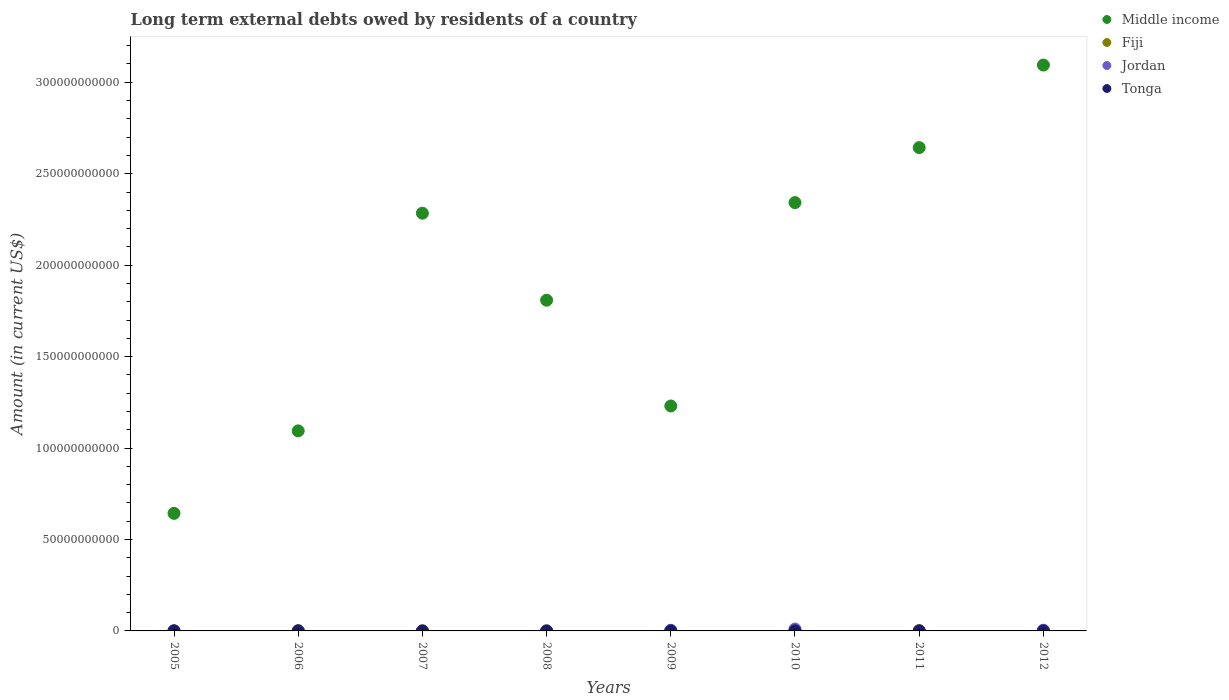Is the number of dotlines equal to the number of legend labels?
Provide a short and direct response. No. What is the amount of long-term external debts owed by residents in Middle income in 2006?
Provide a short and direct response. 1.09e+11. Across all years, what is the maximum amount of long-term external debts owed by residents in Middle income?
Make the answer very short. 3.09e+11. Across all years, what is the minimum amount of long-term external debts owed by residents in Middle income?
Your answer should be very brief. 6.43e+1. What is the total amount of long-term external debts owed by residents in Middle income in the graph?
Give a very brief answer. 1.51e+12. What is the difference between the amount of long-term external debts owed by residents in Tonga in 2008 and that in 2009?
Offer a terse response. -1.02e+07. What is the difference between the amount of long-term external debts owed by residents in Jordan in 2011 and the amount of long-term external debts owed by residents in Tonga in 2010?
Ensure brevity in your answer.  -3.82e+07. What is the average amount of long-term external debts owed by residents in Fiji per year?
Offer a terse response. 5.20e+07. In the year 2006, what is the difference between the amount of long-term external debts owed by residents in Fiji and amount of long-term external debts owed by residents in Middle income?
Keep it short and to the point. -1.09e+11. What is the ratio of the amount of long-term external debts owed by residents in Tonga in 2005 to that in 2008?
Give a very brief answer. 0.18. What is the difference between the highest and the second highest amount of long-term external debts owed by residents in Tonga?
Your answer should be very brief. 4.60e+06. What is the difference between the highest and the lowest amount of long-term external debts owed by residents in Jordan?
Provide a short and direct response. 1.02e+09. In how many years, is the amount of long-term external debts owed by residents in Middle income greater than the average amount of long-term external debts owed by residents in Middle income taken over all years?
Keep it short and to the point. 4. Is the sum of the amount of long-term external debts owed by residents in Tonga in 2005 and 2012 greater than the maximum amount of long-term external debts owed by residents in Fiji across all years?
Ensure brevity in your answer.  No. Is it the case that in every year, the sum of the amount of long-term external debts owed by residents in Tonga and amount of long-term external debts owed by residents in Jordan  is greater than the amount of long-term external debts owed by residents in Fiji?
Offer a very short reply. No. Is the amount of long-term external debts owed by residents in Jordan strictly greater than the amount of long-term external debts owed by residents in Middle income over the years?
Provide a short and direct response. No. Is the amount of long-term external debts owed by residents in Fiji strictly less than the amount of long-term external debts owed by residents in Middle income over the years?
Make the answer very short. Yes. Are the values on the major ticks of Y-axis written in scientific E-notation?
Your answer should be compact. No. Does the graph contain any zero values?
Ensure brevity in your answer.  Yes. What is the title of the graph?
Your response must be concise. Long term external debts owed by residents of a country. Does "Bhutan" appear as one of the legend labels in the graph?
Give a very brief answer. No. What is the label or title of the X-axis?
Your answer should be compact. Years. What is the label or title of the Y-axis?
Give a very brief answer. Amount (in current US$). What is the Amount (in current US$) of Middle income in 2005?
Offer a terse response. 6.43e+1. What is the Amount (in current US$) of Fiji in 2005?
Make the answer very short. 5.53e+06. What is the Amount (in current US$) in Jordan in 2005?
Your answer should be very brief. 6.78e+07. What is the Amount (in current US$) of Tonga in 2005?
Offer a very short reply. 8.68e+05. What is the Amount (in current US$) of Middle income in 2006?
Provide a succinct answer. 1.09e+11. What is the Amount (in current US$) in Fiji in 2006?
Keep it short and to the point. 1.55e+08. What is the Amount (in current US$) of Middle income in 2007?
Your answer should be compact. 2.28e+11. What is the Amount (in current US$) in Fiji in 2007?
Offer a terse response. 2.23e+06. What is the Amount (in current US$) in Jordan in 2007?
Provide a short and direct response. 0. What is the Amount (in current US$) of Tonga in 2007?
Keep it short and to the point. 8.95e+05. What is the Amount (in current US$) of Middle income in 2008?
Offer a very short reply. 1.81e+11. What is the Amount (in current US$) in Fiji in 2008?
Offer a terse response. 5.63e+06. What is the Amount (in current US$) in Tonga in 2008?
Your response must be concise. 4.80e+06. What is the Amount (in current US$) of Middle income in 2009?
Your response must be concise. 1.23e+11. What is the Amount (in current US$) in Fiji in 2009?
Your answer should be very brief. 4.86e+06. What is the Amount (in current US$) in Jordan in 2009?
Make the answer very short. 3.62e+08. What is the Amount (in current US$) in Tonga in 2009?
Offer a very short reply. 1.49e+07. What is the Amount (in current US$) in Middle income in 2010?
Provide a short and direct response. 2.34e+11. What is the Amount (in current US$) in Fiji in 2010?
Your answer should be very brief. 2.35e+07. What is the Amount (in current US$) in Jordan in 2010?
Your answer should be very brief. 1.02e+09. What is the Amount (in current US$) of Tonga in 2010?
Provide a succinct answer. 3.82e+07. What is the Amount (in current US$) in Middle income in 2011?
Provide a succinct answer. 2.64e+11. What is the Amount (in current US$) of Fiji in 2011?
Provide a short and direct response. 1.52e+08. What is the Amount (in current US$) in Tonga in 2011?
Offer a very short reply. 3.36e+07. What is the Amount (in current US$) of Middle income in 2012?
Make the answer very short. 3.09e+11. What is the Amount (in current US$) in Fiji in 2012?
Offer a very short reply. 6.71e+07. What is the Amount (in current US$) of Jordan in 2012?
Give a very brief answer. 3.95e+08. What is the Amount (in current US$) in Tonga in 2012?
Provide a short and direct response. 6.46e+06. Across all years, what is the maximum Amount (in current US$) of Middle income?
Offer a terse response. 3.09e+11. Across all years, what is the maximum Amount (in current US$) of Fiji?
Keep it short and to the point. 1.55e+08. Across all years, what is the maximum Amount (in current US$) of Jordan?
Offer a terse response. 1.02e+09. Across all years, what is the maximum Amount (in current US$) in Tonga?
Provide a succinct answer. 3.82e+07. Across all years, what is the minimum Amount (in current US$) in Middle income?
Provide a succinct answer. 6.43e+1. Across all years, what is the minimum Amount (in current US$) of Fiji?
Your answer should be very brief. 2.23e+06. Across all years, what is the minimum Amount (in current US$) of Jordan?
Provide a succinct answer. 0. Across all years, what is the minimum Amount (in current US$) in Tonga?
Give a very brief answer. 0. What is the total Amount (in current US$) of Middle income in the graph?
Offer a very short reply. 1.51e+12. What is the total Amount (in current US$) of Fiji in the graph?
Your response must be concise. 4.16e+08. What is the total Amount (in current US$) in Jordan in the graph?
Ensure brevity in your answer.  1.85e+09. What is the total Amount (in current US$) in Tonga in the graph?
Offer a terse response. 9.99e+07. What is the difference between the Amount (in current US$) of Middle income in 2005 and that in 2006?
Your answer should be compact. -4.51e+1. What is the difference between the Amount (in current US$) in Fiji in 2005 and that in 2006?
Ensure brevity in your answer.  -1.50e+08. What is the difference between the Amount (in current US$) of Middle income in 2005 and that in 2007?
Your response must be concise. -1.64e+11. What is the difference between the Amount (in current US$) in Fiji in 2005 and that in 2007?
Offer a terse response. 3.30e+06. What is the difference between the Amount (in current US$) of Tonga in 2005 and that in 2007?
Make the answer very short. -2.70e+04. What is the difference between the Amount (in current US$) in Middle income in 2005 and that in 2008?
Ensure brevity in your answer.  -1.17e+11. What is the difference between the Amount (in current US$) in Fiji in 2005 and that in 2008?
Your answer should be compact. -1.01e+05. What is the difference between the Amount (in current US$) of Tonga in 2005 and that in 2008?
Your answer should be very brief. -3.93e+06. What is the difference between the Amount (in current US$) of Middle income in 2005 and that in 2009?
Ensure brevity in your answer.  -5.87e+1. What is the difference between the Amount (in current US$) of Fiji in 2005 and that in 2009?
Ensure brevity in your answer.  6.65e+05. What is the difference between the Amount (in current US$) of Jordan in 2005 and that in 2009?
Offer a very short reply. -2.94e+08. What is the difference between the Amount (in current US$) of Tonga in 2005 and that in 2009?
Give a very brief answer. -1.41e+07. What is the difference between the Amount (in current US$) of Middle income in 2005 and that in 2010?
Ensure brevity in your answer.  -1.70e+11. What is the difference between the Amount (in current US$) of Fiji in 2005 and that in 2010?
Keep it short and to the point. -1.79e+07. What is the difference between the Amount (in current US$) of Jordan in 2005 and that in 2010?
Make the answer very short. -9.57e+08. What is the difference between the Amount (in current US$) in Tonga in 2005 and that in 2010?
Keep it short and to the point. -3.74e+07. What is the difference between the Amount (in current US$) in Middle income in 2005 and that in 2011?
Your answer should be very brief. -2.00e+11. What is the difference between the Amount (in current US$) in Fiji in 2005 and that in 2011?
Provide a short and direct response. -1.46e+08. What is the difference between the Amount (in current US$) in Tonga in 2005 and that in 2011?
Give a very brief answer. -3.28e+07. What is the difference between the Amount (in current US$) of Middle income in 2005 and that in 2012?
Your response must be concise. -2.45e+11. What is the difference between the Amount (in current US$) of Fiji in 2005 and that in 2012?
Your answer should be compact. -6.16e+07. What is the difference between the Amount (in current US$) of Jordan in 2005 and that in 2012?
Provide a succinct answer. -3.27e+08. What is the difference between the Amount (in current US$) in Tonga in 2005 and that in 2012?
Provide a succinct answer. -5.59e+06. What is the difference between the Amount (in current US$) in Middle income in 2006 and that in 2007?
Offer a terse response. -1.19e+11. What is the difference between the Amount (in current US$) of Fiji in 2006 and that in 2007?
Provide a short and direct response. 1.53e+08. What is the difference between the Amount (in current US$) of Middle income in 2006 and that in 2008?
Provide a short and direct response. -7.15e+1. What is the difference between the Amount (in current US$) in Fiji in 2006 and that in 2008?
Give a very brief answer. 1.50e+08. What is the difference between the Amount (in current US$) in Middle income in 2006 and that in 2009?
Your answer should be compact. -1.36e+1. What is the difference between the Amount (in current US$) of Fiji in 2006 and that in 2009?
Make the answer very short. 1.50e+08. What is the difference between the Amount (in current US$) in Middle income in 2006 and that in 2010?
Offer a terse response. -1.25e+11. What is the difference between the Amount (in current US$) of Fiji in 2006 and that in 2010?
Give a very brief answer. 1.32e+08. What is the difference between the Amount (in current US$) in Middle income in 2006 and that in 2011?
Your response must be concise. -1.55e+11. What is the difference between the Amount (in current US$) of Fiji in 2006 and that in 2011?
Ensure brevity in your answer.  3.40e+06. What is the difference between the Amount (in current US$) in Middle income in 2006 and that in 2012?
Make the answer very short. -2.00e+11. What is the difference between the Amount (in current US$) of Fiji in 2006 and that in 2012?
Your answer should be very brief. 8.81e+07. What is the difference between the Amount (in current US$) of Middle income in 2007 and that in 2008?
Keep it short and to the point. 4.76e+1. What is the difference between the Amount (in current US$) in Fiji in 2007 and that in 2008?
Keep it short and to the point. -3.40e+06. What is the difference between the Amount (in current US$) in Tonga in 2007 and that in 2008?
Your response must be concise. -3.90e+06. What is the difference between the Amount (in current US$) in Middle income in 2007 and that in 2009?
Ensure brevity in your answer.  1.05e+11. What is the difference between the Amount (in current US$) in Fiji in 2007 and that in 2009?
Offer a very short reply. -2.64e+06. What is the difference between the Amount (in current US$) in Tonga in 2007 and that in 2009?
Offer a very short reply. -1.41e+07. What is the difference between the Amount (in current US$) in Middle income in 2007 and that in 2010?
Offer a very short reply. -5.80e+09. What is the difference between the Amount (in current US$) in Fiji in 2007 and that in 2010?
Your answer should be compact. -2.12e+07. What is the difference between the Amount (in current US$) in Tonga in 2007 and that in 2010?
Offer a very short reply. -3.74e+07. What is the difference between the Amount (in current US$) of Middle income in 2007 and that in 2011?
Give a very brief answer. -3.59e+1. What is the difference between the Amount (in current US$) of Fiji in 2007 and that in 2011?
Offer a terse response. -1.50e+08. What is the difference between the Amount (in current US$) in Tonga in 2007 and that in 2011?
Give a very brief answer. -3.28e+07. What is the difference between the Amount (in current US$) in Middle income in 2007 and that in 2012?
Provide a short and direct response. -8.10e+1. What is the difference between the Amount (in current US$) in Fiji in 2007 and that in 2012?
Offer a very short reply. -6.49e+07. What is the difference between the Amount (in current US$) of Tonga in 2007 and that in 2012?
Provide a short and direct response. -5.56e+06. What is the difference between the Amount (in current US$) of Middle income in 2008 and that in 2009?
Your answer should be compact. 5.78e+1. What is the difference between the Amount (in current US$) in Fiji in 2008 and that in 2009?
Your answer should be very brief. 7.66e+05. What is the difference between the Amount (in current US$) in Tonga in 2008 and that in 2009?
Provide a succinct answer. -1.02e+07. What is the difference between the Amount (in current US$) of Middle income in 2008 and that in 2010?
Your response must be concise. -5.34e+1. What is the difference between the Amount (in current US$) in Fiji in 2008 and that in 2010?
Provide a short and direct response. -1.78e+07. What is the difference between the Amount (in current US$) in Tonga in 2008 and that in 2010?
Your response must be concise. -3.34e+07. What is the difference between the Amount (in current US$) in Middle income in 2008 and that in 2011?
Make the answer very short. -8.34e+1. What is the difference between the Amount (in current US$) in Fiji in 2008 and that in 2011?
Provide a short and direct response. -1.46e+08. What is the difference between the Amount (in current US$) in Tonga in 2008 and that in 2011?
Offer a terse response. -2.89e+07. What is the difference between the Amount (in current US$) in Middle income in 2008 and that in 2012?
Your answer should be compact. -1.29e+11. What is the difference between the Amount (in current US$) in Fiji in 2008 and that in 2012?
Offer a very short reply. -6.15e+07. What is the difference between the Amount (in current US$) of Tonga in 2008 and that in 2012?
Make the answer very short. -1.66e+06. What is the difference between the Amount (in current US$) in Middle income in 2009 and that in 2010?
Keep it short and to the point. -1.11e+11. What is the difference between the Amount (in current US$) in Fiji in 2009 and that in 2010?
Offer a terse response. -1.86e+07. What is the difference between the Amount (in current US$) in Jordan in 2009 and that in 2010?
Offer a terse response. -6.63e+08. What is the difference between the Amount (in current US$) of Tonga in 2009 and that in 2010?
Give a very brief answer. -2.33e+07. What is the difference between the Amount (in current US$) in Middle income in 2009 and that in 2011?
Your response must be concise. -1.41e+11. What is the difference between the Amount (in current US$) of Fiji in 2009 and that in 2011?
Provide a short and direct response. -1.47e+08. What is the difference between the Amount (in current US$) of Tonga in 2009 and that in 2011?
Make the answer very short. -1.87e+07. What is the difference between the Amount (in current US$) in Middle income in 2009 and that in 2012?
Offer a very short reply. -1.86e+11. What is the difference between the Amount (in current US$) in Fiji in 2009 and that in 2012?
Make the answer very short. -6.22e+07. What is the difference between the Amount (in current US$) in Jordan in 2009 and that in 2012?
Make the answer very short. -3.30e+07. What is the difference between the Amount (in current US$) of Tonga in 2009 and that in 2012?
Offer a terse response. 8.49e+06. What is the difference between the Amount (in current US$) in Middle income in 2010 and that in 2011?
Make the answer very short. -3.01e+1. What is the difference between the Amount (in current US$) in Fiji in 2010 and that in 2011?
Give a very brief answer. -1.28e+08. What is the difference between the Amount (in current US$) of Tonga in 2010 and that in 2011?
Your response must be concise. 4.60e+06. What is the difference between the Amount (in current US$) in Middle income in 2010 and that in 2012?
Your response must be concise. -7.52e+1. What is the difference between the Amount (in current US$) of Fiji in 2010 and that in 2012?
Your answer should be compact. -4.36e+07. What is the difference between the Amount (in current US$) of Jordan in 2010 and that in 2012?
Your answer should be compact. 6.30e+08. What is the difference between the Amount (in current US$) in Tonga in 2010 and that in 2012?
Give a very brief answer. 3.18e+07. What is the difference between the Amount (in current US$) of Middle income in 2011 and that in 2012?
Offer a very short reply. -4.51e+1. What is the difference between the Amount (in current US$) in Fiji in 2011 and that in 2012?
Make the answer very short. 8.47e+07. What is the difference between the Amount (in current US$) of Tonga in 2011 and that in 2012?
Ensure brevity in your answer.  2.72e+07. What is the difference between the Amount (in current US$) in Middle income in 2005 and the Amount (in current US$) in Fiji in 2006?
Provide a short and direct response. 6.41e+1. What is the difference between the Amount (in current US$) of Middle income in 2005 and the Amount (in current US$) of Fiji in 2007?
Provide a short and direct response. 6.43e+1. What is the difference between the Amount (in current US$) in Middle income in 2005 and the Amount (in current US$) in Tonga in 2007?
Offer a very short reply. 6.43e+1. What is the difference between the Amount (in current US$) in Fiji in 2005 and the Amount (in current US$) in Tonga in 2007?
Provide a succinct answer. 4.63e+06. What is the difference between the Amount (in current US$) of Jordan in 2005 and the Amount (in current US$) of Tonga in 2007?
Your answer should be compact. 6.69e+07. What is the difference between the Amount (in current US$) of Middle income in 2005 and the Amount (in current US$) of Fiji in 2008?
Your answer should be compact. 6.43e+1. What is the difference between the Amount (in current US$) in Middle income in 2005 and the Amount (in current US$) in Tonga in 2008?
Your response must be concise. 6.43e+1. What is the difference between the Amount (in current US$) in Fiji in 2005 and the Amount (in current US$) in Tonga in 2008?
Offer a very short reply. 7.30e+05. What is the difference between the Amount (in current US$) of Jordan in 2005 and the Amount (in current US$) of Tonga in 2008?
Provide a short and direct response. 6.30e+07. What is the difference between the Amount (in current US$) in Middle income in 2005 and the Amount (in current US$) in Fiji in 2009?
Provide a succinct answer. 6.43e+1. What is the difference between the Amount (in current US$) of Middle income in 2005 and the Amount (in current US$) of Jordan in 2009?
Your response must be concise. 6.39e+1. What is the difference between the Amount (in current US$) in Middle income in 2005 and the Amount (in current US$) in Tonga in 2009?
Your answer should be compact. 6.43e+1. What is the difference between the Amount (in current US$) in Fiji in 2005 and the Amount (in current US$) in Jordan in 2009?
Ensure brevity in your answer.  -3.56e+08. What is the difference between the Amount (in current US$) of Fiji in 2005 and the Amount (in current US$) of Tonga in 2009?
Your answer should be compact. -9.42e+06. What is the difference between the Amount (in current US$) of Jordan in 2005 and the Amount (in current US$) of Tonga in 2009?
Offer a very short reply. 5.29e+07. What is the difference between the Amount (in current US$) of Middle income in 2005 and the Amount (in current US$) of Fiji in 2010?
Offer a terse response. 6.43e+1. What is the difference between the Amount (in current US$) of Middle income in 2005 and the Amount (in current US$) of Jordan in 2010?
Provide a succinct answer. 6.33e+1. What is the difference between the Amount (in current US$) in Middle income in 2005 and the Amount (in current US$) in Tonga in 2010?
Ensure brevity in your answer.  6.42e+1. What is the difference between the Amount (in current US$) of Fiji in 2005 and the Amount (in current US$) of Jordan in 2010?
Your answer should be very brief. -1.02e+09. What is the difference between the Amount (in current US$) of Fiji in 2005 and the Amount (in current US$) of Tonga in 2010?
Your response must be concise. -3.27e+07. What is the difference between the Amount (in current US$) in Jordan in 2005 and the Amount (in current US$) in Tonga in 2010?
Ensure brevity in your answer.  2.96e+07. What is the difference between the Amount (in current US$) of Middle income in 2005 and the Amount (in current US$) of Fiji in 2011?
Your answer should be very brief. 6.41e+1. What is the difference between the Amount (in current US$) in Middle income in 2005 and the Amount (in current US$) in Tonga in 2011?
Your answer should be very brief. 6.42e+1. What is the difference between the Amount (in current US$) in Fiji in 2005 and the Amount (in current US$) in Tonga in 2011?
Your answer should be compact. -2.81e+07. What is the difference between the Amount (in current US$) of Jordan in 2005 and the Amount (in current US$) of Tonga in 2011?
Offer a terse response. 3.42e+07. What is the difference between the Amount (in current US$) in Middle income in 2005 and the Amount (in current US$) in Fiji in 2012?
Give a very brief answer. 6.42e+1. What is the difference between the Amount (in current US$) of Middle income in 2005 and the Amount (in current US$) of Jordan in 2012?
Your answer should be compact. 6.39e+1. What is the difference between the Amount (in current US$) in Middle income in 2005 and the Amount (in current US$) in Tonga in 2012?
Make the answer very short. 6.43e+1. What is the difference between the Amount (in current US$) in Fiji in 2005 and the Amount (in current US$) in Jordan in 2012?
Offer a very short reply. -3.89e+08. What is the difference between the Amount (in current US$) in Fiji in 2005 and the Amount (in current US$) in Tonga in 2012?
Your answer should be compact. -9.31e+05. What is the difference between the Amount (in current US$) in Jordan in 2005 and the Amount (in current US$) in Tonga in 2012?
Offer a terse response. 6.14e+07. What is the difference between the Amount (in current US$) of Middle income in 2006 and the Amount (in current US$) of Fiji in 2007?
Provide a succinct answer. 1.09e+11. What is the difference between the Amount (in current US$) of Middle income in 2006 and the Amount (in current US$) of Tonga in 2007?
Keep it short and to the point. 1.09e+11. What is the difference between the Amount (in current US$) in Fiji in 2006 and the Amount (in current US$) in Tonga in 2007?
Ensure brevity in your answer.  1.54e+08. What is the difference between the Amount (in current US$) in Middle income in 2006 and the Amount (in current US$) in Fiji in 2008?
Offer a terse response. 1.09e+11. What is the difference between the Amount (in current US$) of Middle income in 2006 and the Amount (in current US$) of Tonga in 2008?
Offer a very short reply. 1.09e+11. What is the difference between the Amount (in current US$) of Fiji in 2006 and the Amount (in current US$) of Tonga in 2008?
Ensure brevity in your answer.  1.50e+08. What is the difference between the Amount (in current US$) in Middle income in 2006 and the Amount (in current US$) in Fiji in 2009?
Provide a succinct answer. 1.09e+11. What is the difference between the Amount (in current US$) in Middle income in 2006 and the Amount (in current US$) in Jordan in 2009?
Ensure brevity in your answer.  1.09e+11. What is the difference between the Amount (in current US$) of Middle income in 2006 and the Amount (in current US$) of Tonga in 2009?
Give a very brief answer. 1.09e+11. What is the difference between the Amount (in current US$) of Fiji in 2006 and the Amount (in current US$) of Jordan in 2009?
Keep it short and to the point. -2.07e+08. What is the difference between the Amount (in current US$) of Fiji in 2006 and the Amount (in current US$) of Tonga in 2009?
Provide a succinct answer. 1.40e+08. What is the difference between the Amount (in current US$) of Middle income in 2006 and the Amount (in current US$) of Fiji in 2010?
Your answer should be compact. 1.09e+11. What is the difference between the Amount (in current US$) in Middle income in 2006 and the Amount (in current US$) in Jordan in 2010?
Offer a terse response. 1.08e+11. What is the difference between the Amount (in current US$) of Middle income in 2006 and the Amount (in current US$) of Tonga in 2010?
Make the answer very short. 1.09e+11. What is the difference between the Amount (in current US$) of Fiji in 2006 and the Amount (in current US$) of Jordan in 2010?
Make the answer very short. -8.70e+08. What is the difference between the Amount (in current US$) in Fiji in 2006 and the Amount (in current US$) in Tonga in 2010?
Your response must be concise. 1.17e+08. What is the difference between the Amount (in current US$) in Middle income in 2006 and the Amount (in current US$) in Fiji in 2011?
Your answer should be very brief. 1.09e+11. What is the difference between the Amount (in current US$) in Middle income in 2006 and the Amount (in current US$) in Tonga in 2011?
Provide a succinct answer. 1.09e+11. What is the difference between the Amount (in current US$) in Fiji in 2006 and the Amount (in current US$) in Tonga in 2011?
Offer a very short reply. 1.22e+08. What is the difference between the Amount (in current US$) of Middle income in 2006 and the Amount (in current US$) of Fiji in 2012?
Ensure brevity in your answer.  1.09e+11. What is the difference between the Amount (in current US$) in Middle income in 2006 and the Amount (in current US$) in Jordan in 2012?
Provide a succinct answer. 1.09e+11. What is the difference between the Amount (in current US$) in Middle income in 2006 and the Amount (in current US$) in Tonga in 2012?
Make the answer very short. 1.09e+11. What is the difference between the Amount (in current US$) in Fiji in 2006 and the Amount (in current US$) in Jordan in 2012?
Ensure brevity in your answer.  -2.40e+08. What is the difference between the Amount (in current US$) in Fiji in 2006 and the Amount (in current US$) in Tonga in 2012?
Keep it short and to the point. 1.49e+08. What is the difference between the Amount (in current US$) of Middle income in 2007 and the Amount (in current US$) of Fiji in 2008?
Give a very brief answer. 2.28e+11. What is the difference between the Amount (in current US$) in Middle income in 2007 and the Amount (in current US$) in Tonga in 2008?
Your answer should be very brief. 2.28e+11. What is the difference between the Amount (in current US$) in Fiji in 2007 and the Amount (in current US$) in Tonga in 2008?
Keep it short and to the point. -2.57e+06. What is the difference between the Amount (in current US$) in Middle income in 2007 and the Amount (in current US$) in Fiji in 2009?
Provide a short and direct response. 2.28e+11. What is the difference between the Amount (in current US$) in Middle income in 2007 and the Amount (in current US$) in Jordan in 2009?
Offer a very short reply. 2.28e+11. What is the difference between the Amount (in current US$) of Middle income in 2007 and the Amount (in current US$) of Tonga in 2009?
Your answer should be compact. 2.28e+11. What is the difference between the Amount (in current US$) of Fiji in 2007 and the Amount (in current US$) of Jordan in 2009?
Make the answer very short. -3.60e+08. What is the difference between the Amount (in current US$) in Fiji in 2007 and the Amount (in current US$) in Tonga in 2009?
Keep it short and to the point. -1.27e+07. What is the difference between the Amount (in current US$) of Middle income in 2007 and the Amount (in current US$) of Fiji in 2010?
Your response must be concise. 2.28e+11. What is the difference between the Amount (in current US$) of Middle income in 2007 and the Amount (in current US$) of Jordan in 2010?
Ensure brevity in your answer.  2.27e+11. What is the difference between the Amount (in current US$) in Middle income in 2007 and the Amount (in current US$) in Tonga in 2010?
Ensure brevity in your answer.  2.28e+11. What is the difference between the Amount (in current US$) in Fiji in 2007 and the Amount (in current US$) in Jordan in 2010?
Give a very brief answer. -1.02e+09. What is the difference between the Amount (in current US$) of Fiji in 2007 and the Amount (in current US$) of Tonga in 2010?
Your answer should be compact. -3.60e+07. What is the difference between the Amount (in current US$) in Middle income in 2007 and the Amount (in current US$) in Fiji in 2011?
Your answer should be very brief. 2.28e+11. What is the difference between the Amount (in current US$) in Middle income in 2007 and the Amount (in current US$) in Tonga in 2011?
Keep it short and to the point. 2.28e+11. What is the difference between the Amount (in current US$) in Fiji in 2007 and the Amount (in current US$) in Tonga in 2011?
Offer a very short reply. -3.14e+07. What is the difference between the Amount (in current US$) in Middle income in 2007 and the Amount (in current US$) in Fiji in 2012?
Offer a terse response. 2.28e+11. What is the difference between the Amount (in current US$) of Middle income in 2007 and the Amount (in current US$) of Jordan in 2012?
Provide a short and direct response. 2.28e+11. What is the difference between the Amount (in current US$) of Middle income in 2007 and the Amount (in current US$) of Tonga in 2012?
Keep it short and to the point. 2.28e+11. What is the difference between the Amount (in current US$) in Fiji in 2007 and the Amount (in current US$) in Jordan in 2012?
Make the answer very short. -3.93e+08. What is the difference between the Amount (in current US$) of Fiji in 2007 and the Amount (in current US$) of Tonga in 2012?
Your answer should be compact. -4.23e+06. What is the difference between the Amount (in current US$) in Middle income in 2008 and the Amount (in current US$) in Fiji in 2009?
Provide a short and direct response. 1.81e+11. What is the difference between the Amount (in current US$) in Middle income in 2008 and the Amount (in current US$) in Jordan in 2009?
Your answer should be compact. 1.80e+11. What is the difference between the Amount (in current US$) in Middle income in 2008 and the Amount (in current US$) in Tonga in 2009?
Provide a succinct answer. 1.81e+11. What is the difference between the Amount (in current US$) of Fiji in 2008 and the Amount (in current US$) of Jordan in 2009?
Offer a very short reply. -3.56e+08. What is the difference between the Amount (in current US$) of Fiji in 2008 and the Amount (in current US$) of Tonga in 2009?
Provide a succinct answer. -9.32e+06. What is the difference between the Amount (in current US$) in Middle income in 2008 and the Amount (in current US$) in Fiji in 2010?
Your response must be concise. 1.81e+11. What is the difference between the Amount (in current US$) in Middle income in 2008 and the Amount (in current US$) in Jordan in 2010?
Keep it short and to the point. 1.80e+11. What is the difference between the Amount (in current US$) of Middle income in 2008 and the Amount (in current US$) of Tonga in 2010?
Provide a short and direct response. 1.81e+11. What is the difference between the Amount (in current US$) of Fiji in 2008 and the Amount (in current US$) of Jordan in 2010?
Keep it short and to the point. -1.02e+09. What is the difference between the Amount (in current US$) in Fiji in 2008 and the Amount (in current US$) in Tonga in 2010?
Your response must be concise. -3.26e+07. What is the difference between the Amount (in current US$) of Middle income in 2008 and the Amount (in current US$) of Fiji in 2011?
Make the answer very short. 1.81e+11. What is the difference between the Amount (in current US$) in Middle income in 2008 and the Amount (in current US$) in Tonga in 2011?
Offer a terse response. 1.81e+11. What is the difference between the Amount (in current US$) in Fiji in 2008 and the Amount (in current US$) in Tonga in 2011?
Your answer should be compact. -2.80e+07. What is the difference between the Amount (in current US$) in Middle income in 2008 and the Amount (in current US$) in Fiji in 2012?
Offer a terse response. 1.81e+11. What is the difference between the Amount (in current US$) in Middle income in 2008 and the Amount (in current US$) in Jordan in 2012?
Keep it short and to the point. 1.80e+11. What is the difference between the Amount (in current US$) in Middle income in 2008 and the Amount (in current US$) in Tonga in 2012?
Offer a terse response. 1.81e+11. What is the difference between the Amount (in current US$) in Fiji in 2008 and the Amount (in current US$) in Jordan in 2012?
Ensure brevity in your answer.  -3.89e+08. What is the difference between the Amount (in current US$) in Fiji in 2008 and the Amount (in current US$) in Tonga in 2012?
Offer a very short reply. -8.30e+05. What is the difference between the Amount (in current US$) of Middle income in 2009 and the Amount (in current US$) of Fiji in 2010?
Offer a very short reply. 1.23e+11. What is the difference between the Amount (in current US$) of Middle income in 2009 and the Amount (in current US$) of Jordan in 2010?
Give a very brief answer. 1.22e+11. What is the difference between the Amount (in current US$) in Middle income in 2009 and the Amount (in current US$) in Tonga in 2010?
Your response must be concise. 1.23e+11. What is the difference between the Amount (in current US$) in Fiji in 2009 and the Amount (in current US$) in Jordan in 2010?
Your answer should be very brief. -1.02e+09. What is the difference between the Amount (in current US$) in Fiji in 2009 and the Amount (in current US$) in Tonga in 2010?
Provide a short and direct response. -3.34e+07. What is the difference between the Amount (in current US$) in Jordan in 2009 and the Amount (in current US$) in Tonga in 2010?
Make the answer very short. 3.24e+08. What is the difference between the Amount (in current US$) of Middle income in 2009 and the Amount (in current US$) of Fiji in 2011?
Your answer should be compact. 1.23e+11. What is the difference between the Amount (in current US$) in Middle income in 2009 and the Amount (in current US$) in Tonga in 2011?
Make the answer very short. 1.23e+11. What is the difference between the Amount (in current US$) in Fiji in 2009 and the Amount (in current US$) in Tonga in 2011?
Make the answer very short. -2.88e+07. What is the difference between the Amount (in current US$) of Jordan in 2009 and the Amount (in current US$) of Tonga in 2011?
Make the answer very short. 3.28e+08. What is the difference between the Amount (in current US$) of Middle income in 2009 and the Amount (in current US$) of Fiji in 2012?
Your response must be concise. 1.23e+11. What is the difference between the Amount (in current US$) of Middle income in 2009 and the Amount (in current US$) of Jordan in 2012?
Your answer should be very brief. 1.23e+11. What is the difference between the Amount (in current US$) in Middle income in 2009 and the Amount (in current US$) in Tonga in 2012?
Provide a short and direct response. 1.23e+11. What is the difference between the Amount (in current US$) of Fiji in 2009 and the Amount (in current US$) of Jordan in 2012?
Offer a very short reply. -3.90e+08. What is the difference between the Amount (in current US$) of Fiji in 2009 and the Amount (in current US$) of Tonga in 2012?
Ensure brevity in your answer.  -1.60e+06. What is the difference between the Amount (in current US$) of Jordan in 2009 and the Amount (in current US$) of Tonga in 2012?
Your answer should be compact. 3.55e+08. What is the difference between the Amount (in current US$) of Middle income in 2010 and the Amount (in current US$) of Fiji in 2011?
Ensure brevity in your answer.  2.34e+11. What is the difference between the Amount (in current US$) of Middle income in 2010 and the Amount (in current US$) of Tonga in 2011?
Your answer should be very brief. 2.34e+11. What is the difference between the Amount (in current US$) of Fiji in 2010 and the Amount (in current US$) of Tonga in 2011?
Your answer should be very brief. -1.02e+07. What is the difference between the Amount (in current US$) of Jordan in 2010 and the Amount (in current US$) of Tonga in 2011?
Offer a terse response. 9.91e+08. What is the difference between the Amount (in current US$) of Middle income in 2010 and the Amount (in current US$) of Fiji in 2012?
Your answer should be compact. 2.34e+11. What is the difference between the Amount (in current US$) of Middle income in 2010 and the Amount (in current US$) of Jordan in 2012?
Ensure brevity in your answer.  2.34e+11. What is the difference between the Amount (in current US$) in Middle income in 2010 and the Amount (in current US$) in Tonga in 2012?
Offer a terse response. 2.34e+11. What is the difference between the Amount (in current US$) in Fiji in 2010 and the Amount (in current US$) in Jordan in 2012?
Make the answer very short. -3.71e+08. What is the difference between the Amount (in current US$) of Fiji in 2010 and the Amount (in current US$) of Tonga in 2012?
Provide a short and direct response. 1.70e+07. What is the difference between the Amount (in current US$) of Jordan in 2010 and the Amount (in current US$) of Tonga in 2012?
Your answer should be compact. 1.02e+09. What is the difference between the Amount (in current US$) in Middle income in 2011 and the Amount (in current US$) in Fiji in 2012?
Provide a short and direct response. 2.64e+11. What is the difference between the Amount (in current US$) of Middle income in 2011 and the Amount (in current US$) of Jordan in 2012?
Ensure brevity in your answer.  2.64e+11. What is the difference between the Amount (in current US$) in Middle income in 2011 and the Amount (in current US$) in Tonga in 2012?
Make the answer very short. 2.64e+11. What is the difference between the Amount (in current US$) in Fiji in 2011 and the Amount (in current US$) in Jordan in 2012?
Keep it short and to the point. -2.43e+08. What is the difference between the Amount (in current US$) in Fiji in 2011 and the Amount (in current US$) in Tonga in 2012?
Keep it short and to the point. 1.45e+08. What is the average Amount (in current US$) of Middle income per year?
Provide a short and direct response. 1.89e+11. What is the average Amount (in current US$) in Fiji per year?
Provide a short and direct response. 5.20e+07. What is the average Amount (in current US$) in Jordan per year?
Your answer should be compact. 2.31e+08. What is the average Amount (in current US$) of Tonga per year?
Provide a short and direct response. 1.25e+07. In the year 2005, what is the difference between the Amount (in current US$) in Middle income and Amount (in current US$) in Fiji?
Your answer should be very brief. 6.43e+1. In the year 2005, what is the difference between the Amount (in current US$) of Middle income and Amount (in current US$) of Jordan?
Make the answer very short. 6.42e+1. In the year 2005, what is the difference between the Amount (in current US$) in Middle income and Amount (in current US$) in Tonga?
Your answer should be compact. 6.43e+1. In the year 2005, what is the difference between the Amount (in current US$) in Fiji and Amount (in current US$) in Jordan?
Keep it short and to the point. -6.23e+07. In the year 2005, what is the difference between the Amount (in current US$) of Fiji and Amount (in current US$) of Tonga?
Offer a terse response. 4.66e+06. In the year 2005, what is the difference between the Amount (in current US$) in Jordan and Amount (in current US$) in Tonga?
Provide a short and direct response. 6.69e+07. In the year 2006, what is the difference between the Amount (in current US$) of Middle income and Amount (in current US$) of Fiji?
Offer a very short reply. 1.09e+11. In the year 2007, what is the difference between the Amount (in current US$) in Middle income and Amount (in current US$) in Fiji?
Give a very brief answer. 2.28e+11. In the year 2007, what is the difference between the Amount (in current US$) of Middle income and Amount (in current US$) of Tonga?
Give a very brief answer. 2.28e+11. In the year 2007, what is the difference between the Amount (in current US$) of Fiji and Amount (in current US$) of Tonga?
Your response must be concise. 1.33e+06. In the year 2008, what is the difference between the Amount (in current US$) in Middle income and Amount (in current US$) in Fiji?
Your response must be concise. 1.81e+11. In the year 2008, what is the difference between the Amount (in current US$) in Middle income and Amount (in current US$) in Tonga?
Provide a succinct answer. 1.81e+11. In the year 2008, what is the difference between the Amount (in current US$) of Fiji and Amount (in current US$) of Tonga?
Your answer should be compact. 8.31e+05. In the year 2009, what is the difference between the Amount (in current US$) in Middle income and Amount (in current US$) in Fiji?
Your response must be concise. 1.23e+11. In the year 2009, what is the difference between the Amount (in current US$) of Middle income and Amount (in current US$) of Jordan?
Ensure brevity in your answer.  1.23e+11. In the year 2009, what is the difference between the Amount (in current US$) in Middle income and Amount (in current US$) in Tonga?
Make the answer very short. 1.23e+11. In the year 2009, what is the difference between the Amount (in current US$) in Fiji and Amount (in current US$) in Jordan?
Keep it short and to the point. -3.57e+08. In the year 2009, what is the difference between the Amount (in current US$) of Fiji and Amount (in current US$) of Tonga?
Keep it short and to the point. -1.01e+07. In the year 2009, what is the difference between the Amount (in current US$) in Jordan and Amount (in current US$) in Tonga?
Your answer should be compact. 3.47e+08. In the year 2010, what is the difference between the Amount (in current US$) of Middle income and Amount (in current US$) of Fiji?
Offer a very short reply. 2.34e+11. In the year 2010, what is the difference between the Amount (in current US$) of Middle income and Amount (in current US$) of Jordan?
Your answer should be very brief. 2.33e+11. In the year 2010, what is the difference between the Amount (in current US$) of Middle income and Amount (in current US$) of Tonga?
Give a very brief answer. 2.34e+11. In the year 2010, what is the difference between the Amount (in current US$) in Fiji and Amount (in current US$) in Jordan?
Your answer should be compact. -1.00e+09. In the year 2010, what is the difference between the Amount (in current US$) in Fiji and Amount (in current US$) in Tonga?
Ensure brevity in your answer.  -1.48e+07. In the year 2010, what is the difference between the Amount (in current US$) of Jordan and Amount (in current US$) of Tonga?
Offer a terse response. 9.86e+08. In the year 2011, what is the difference between the Amount (in current US$) of Middle income and Amount (in current US$) of Fiji?
Your answer should be very brief. 2.64e+11. In the year 2011, what is the difference between the Amount (in current US$) of Middle income and Amount (in current US$) of Tonga?
Offer a terse response. 2.64e+11. In the year 2011, what is the difference between the Amount (in current US$) in Fiji and Amount (in current US$) in Tonga?
Your answer should be compact. 1.18e+08. In the year 2012, what is the difference between the Amount (in current US$) of Middle income and Amount (in current US$) of Fiji?
Give a very brief answer. 3.09e+11. In the year 2012, what is the difference between the Amount (in current US$) of Middle income and Amount (in current US$) of Jordan?
Make the answer very short. 3.09e+11. In the year 2012, what is the difference between the Amount (in current US$) in Middle income and Amount (in current US$) in Tonga?
Make the answer very short. 3.09e+11. In the year 2012, what is the difference between the Amount (in current US$) in Fiji and Amount (in current US$) in Jordan?
Your answer should be compact. -3.28e+08. In the year 2012, what is the difference between the Amount (in current US$) in Fiji and Amount (in current US$) in Tonga?
Make the answer very short. 6.06e+07. In the year 2012, what is the difference between the Amount (in current US$) of Jordan and Amount (in current US$) of Tonga?
Ensure brevity in your answer.  3.88e+08. What is the ratio of the Amount (in current US$) of Middle income in 2005 to that in 2006?
Keep it short and to the point. 0.59. What is the ratio of the Amount (in current US$) of Fiji in 2005 to that in 2006?
Provide a succinct answer. 0.04. What is the ratio of the Amount (in current US$) of Middle income in 2005 to that in 2007?
Your answer should be compact. 0.28. What is the ratio of the Amount (in current US$) of Fiji in 2005 to that in 2007?
Offer a very short reply. 2.48. What is the ratio of the Amount (in current US$) of Tonga in 2005 to that in 2007?
Make the answer very short. 0.97. What is the ratio of the Amount (in current US$) in Middle income in 2005 to that in 2008?
Provide a succinct answer. 0.36. What is the ratio of the Amount (in current US$) of Fiji in 2005 to that in 2008?
Offer a terse response. 0.98. What is the ratio of the Amount (in current US$) in Tonga in 2005 to that in 2008?
Your answer should be very brief. 0.18. What is the ratio of the Amount (in current US$) in Middle income in 2005 to that in 2009?
Offer a very short reply. 0.52. What is the ratio of the Amount (in current US$) of Fiji in 2005 to that in 2009?
Your response must be concise. 1.14. What is the ratio of the Amount (in current US$) in Jordan in 2005 to that in 2009?
Offer a very short reply. 0.19. What is the ratio of the Amount (in current US$) of Tonga in 2005 to that in 2009?
Make the answer very short. 0.06. What is the ratio of the Amount (in current US$) of Middle income in 2005 to that in 2010?
Provide a succinct answer. 0.27. What is the ratio of the Amount (in current US$) of Fiji in 2005 to that in 2010?
Make the answer very short. 0.24. What is the ratio of the Amount (in current US$) in Jordan in 2005 to that in 2010?
Give a very brief answer. 0.07. What is the ratio of the Amount (in current US$) of Tonga in 2005 to that in 2010?
Provide a short and direct response. 0.02. What is the ratio of the Amount (in current US$) in Middle income in 2005 to that in 2011?
Your response must be concise. 0.24. What is the ratio of the Amount (in current US$) in Fiji in 2005 to that in 2011?
Your answer should be very brief. 0.04. What is the ratio of the Amount (in current US$) in Tonga in 2005 to that in 2011?
Keep it short and to the point. 0.03. What is the ratio of the Amount (in current US$) in Middle income in 2005 to that in 2012?
Keep it short and to the point. 0.21. What is the ratio of the Amount (in current US$) in Fiji in 2005 to that in 2012?
Make the answer very short. 0.08. What is the ratio of the Amount (in current US$) of Jordan in 2005 to that in 2012?
Make the answer very short. 0.17. What is the ratio of the Amount (in current US$) in Tonga in 2005 to that in 2012?
Provide a succinct answer. 0.13. What is the ratio of the Amount (in current US$) in Middle income in 2006 to that in 2007?
Your answer should be very brief. 0.48. What is the ratio of the Amount (in current US$) of Fiji in 2006 to that in 2007?
Give a very brief answer. 69.72. What is the ratio of the Amount (in current US$) of Middle income in 2006 to that in 2008?
Your response must be concise. 0.6. What is the ratio of the Amount (in current US$) in Fiji in 2006 to that in 2008?
Your response must be concise. 27.58. What is the ratio of the Amount (in current US$) in Middle income in 2006 to that in 2009?
Make the answer very short. 0.89. What is the ratio of the Amount (in current US$) in Fiji in 2006 to that in 2009?
Offer a very short reply. 31.93. What is the ratio of the Amount (in current US$) in Middle income in 2006 to that in 2010?
Give a very brief answer. 0.47. What is the ratio of the Amount (in current US$) in Fiji in 2006 to that in 2010?
Provide a short and direct response. 6.61. What is the ratio of the Amount (in current US$) of Middle income in 2006 to that in 2011?
Ensure brevity in your answer.  0.41. What is the ratio of the Amount (in current US$) of Fiji in 2006 to that in 2011?
Provide a succinct answer. 1.02. What is the ratio of the Amount (in current US$) of Middle income in 2006 to that in 2012?
Provide a short and direct response. 0.35. What is the ratio of the Amount (in current US$) of Fiji in 2006 to that in 2012?
Offer a very short reply. 2.31. What is the ratio of the Amount (in current US$) in Middle income in 2007 to that in 2008?
Make the answer very short. 1.26. What is the ratio of the Amount (in current US$) in Fiji in 2007 to that in 2008?
Your response must be concise. 0.4. What is the ratio of the Amount (in current US$) in Tonga in 2007 to that in 2008?
Your answer should be compact. 0.19. What is the ratio of the Amount (in current US$) of Middle income in 2007 to that in 2009?
Offer a terse response. 1.86. What is the ratio of the Amount (in current US$) of Fiji in 2007 to that in 2009?
Your answer should be very brief. 0.46. What is the ratio of the Amount (in current US$) of Tonga in 2007 to that in 2009?
Offer a terse response. 0.06. What is the ratio of the Amount (in current US$) in Middle income in 2007 to that in 2010?
Your answer should be compact. 0.98. What is the ratio of the Amount (in current US$) of Fiji in 2007 to that in 2010?
Keep it short and to the point. 0.09. What is the ratio of the Amount (in current US$) in Tonga in 2007 to that in 2010?
Your response must be concise. 0.02. What is the ratio of the Amount (in current US$) of Middle income in 2007 to that in 2011?
Give a very brief answer. 0.86. What is the ratio of the Amount (in current US$) in Fiji in 2007 to that in 2011?
Your response must be concise. 0.01. What is the ratio of the Amount (in current US$) of Tonga in 2007 to that in 2011?
Provide a succinct answer. 0.03. What is the ratio of the Amount (in current US$) of Middle income in 2007 to that in 2012?
Your answer should be compact. 0.74. What is the ratio of the Amount (in current US$) of Fiji in 2007 to that in 2012?
Offer a terse response. 0.03. What is the ratio of the Amount (in current US$) in Tonga in 2007 to that in 2012?
Make the answer very short. 0.14. What is the ratio of the Amount (in current US$) in Middle income in 2008 to that in 2009?
Ensure brevity in your answer.  1.47. What is the ratio of the Amount (in current US$) of Fiji in 2008 to that in 2009?
Your response must be concise. 1.16. What is the ratio of the Amount (in current US$) of Tonga in 2008 to that in 2009?
Your response must be concise. 0.32. What is the ratio of the Amount (in current US$) of Middle income in 2008 to that in 2010?
Offer a very short reply. 0.77. What is the ratio of the Amount (in current US$) in Fiji in 2008 to that in 2010?
Ensure brevity in your answer.  0.24. What is the ratio of the Amount (in current US$) in Tonga in 2008 to that in 2010?
Your answer should be very brief. 0.13. What is the ratio of the Amount (in current US$) in Middle income in 2008 to that in 2011?
Your answer should be very brief. 0.68. What is the ratio of the Amount (in current US$) in Fiji in 2008 to that in 2011?
Give a very brief answer. 0.04. What is the ratio of the Amount (in current US$) in Tonga in 2008 to that in 2011?
Make the answer very short. 0.14. What is the ratio of the Amount (in current US$) of Middle income in 2008 to that in 2012?
Your response must be concise. 0.58. What is the ratio of the Amount (in current US$) of Fiji in 2008 to that in 2012?
Your answer should be compact. 0.08. What is the ratio of the Amount (in current US$) of Tonga in 2008 to that in 2012?
Your answer should be compact. 0.74. What is the ratio of the Amount (in current US$) in Middle income in 2009 to that in 2010?
Offer a very short reply. 0.53. What is the ratio of the Amount (in current US$) of Fiji in 2009 to that in 2010?
Your response must be concise. 0.21. What is the ratio of the Amount (in current US$) in Jordan in 2009 to that in 2010?
Offer a terse response. 0.35. What is the ratio of the Amount (in current US$) of Tonga in 2009 to that in 2010?
Offer a terse response. 0.39. What is the ratio of the Amount (in current US$) of Middle income in 2009 to that in 2011?
Your answer should be very brief. 0.47. What is the ratio of the Amount (in current US$) of Fiji in 2009 to that in 2011?
Your answer should be compact. 0.03. What is the ratio of the Amount (in current US$) in Tonga in 2009 to that in 2011?
Offer a very short reply. 0.44. What is the ratio of the Amount (in current US$) in Middle income in 2009 to that in 2012?
Offer a terse response. 0.4. What is the ratio of the Amount (in current US$) in Fiji in 2009 to that in 2012?
Your response must be concise. 0.07. What is the ratio of the Amount (in current US$) in Jordan in 2009 to that in 2012?
Provide a short and direct response. 0.92. What is the ratio of the Amount (in current US$) of Tonga in 2009 to that in 2012?
Offer a very short reply. 2.31. What is the ratio of the Amount (in current US$) of Middle income in 2010 to that in 2011?
Give a very brief answer. 0.89. What is the ratio of the Amount (in current US$) of Fiji in 2010 to that in 2011?
Provide a succinct answer. 0.15. What is the ratio of the Amount (in current US$) in Tonga in 2010 to that in 2011?
Offer a terse response. 1.14. What is the ratio of the Amount (in current US$) in Middle income in 2010 to that in 2012?
Give a very brief answer. 0.76. What is the ratio of the Amount (in current US$) of Fiji in 2010 to that in 2012?
Keep it short and to the point. 0.35. What is the ratio of the Amount (in current US$) of Jordan in 2010 to that in 2012?
Keep it short and to the point. 2.6. What is the ratio of the Amount (in current US$) of Tonga in 2010 to that in 2012?
Ensure brevity in your answer.  5.92. What is the ratio of the Amount (in current US$) in Middle income in 2011 to that in 2012?
Provide a short and direct response. 0.85. What is the ratio of the Amount (in current US$) in Fiji in 2011 to that in 2012?
Keep it short and to the point. 2.26. What is the ratio of the Amount (in current US$) in Tonga in 2011 to that in 2012?
Your response must be concise. 5.21. What is the difference between the highest and the second highest Amount (in current US$) of Middle income?
Provide a succinct answer. 4.51e+1. What is the difference between the highest and the second highest Amount (in current US$) of Fiji?
Provide a short and direct response. 3.40e+06. What is the difference between the highest and the second highest Amount (in current US$) in Jordan?
Offer a terse response. 6.30e+08. What is the difference between the highest and the second highest Amount (in current US$) in Tonga?
Give a very brief answer. 4.60e+06. What is the difference between the highest and the lowest Amount (in current US$) in Middle income?
Provide a succinct answer. 2.45e+11. What is the difference between the highest and the lowest Amount (in current US$) of Fiji?
Provide a short and direct response. 1.53e+08. What is the difference between the highest and the lowest Amount (in current US$) of Jordan?
Make the answer very short. 1.02e+09. What is the difference between the highest and the lowest Amount (in current US$) of Tonga?
Your response must be concise. 3.82e+07. 